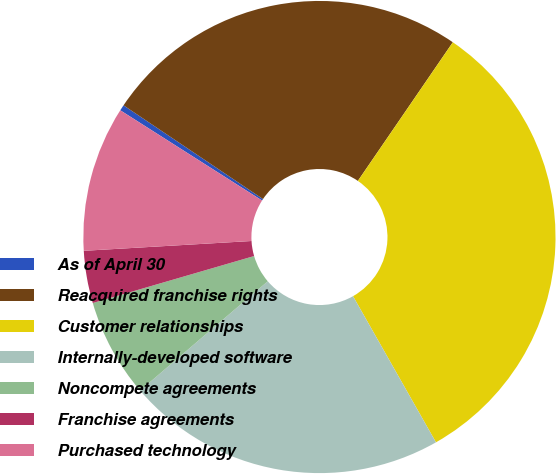<chart> <loc_0><loc_0><loc_500><loc_500><pie_chart><fcel>As of April 30<fcel>Reacquired franchise rights<fcel>Customer relationships<fcel>Internally-developed software<fcel>Noncompete agreements<fcel>Franchise agreements<fcel>Purchased technology<nl><fcel>0.4%<fcel>25.14%<fcel>32.23%<fcel>21.95%<fcel>6.76%<fcel>3.58%<fcel>9.95%<nl></chart> 